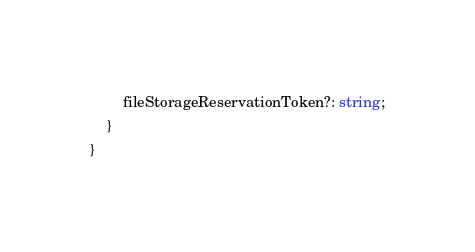Convert code to text. <code><loc_0><loc_0><loc_500><loc_500><_TypeScript_>        fileStorageReservationToken?: string;
    }
}
</code> 